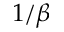Convert formula to latex. <formula><loc_0><loc_0><loc_500><loc_500>1 / \beta</formula> 